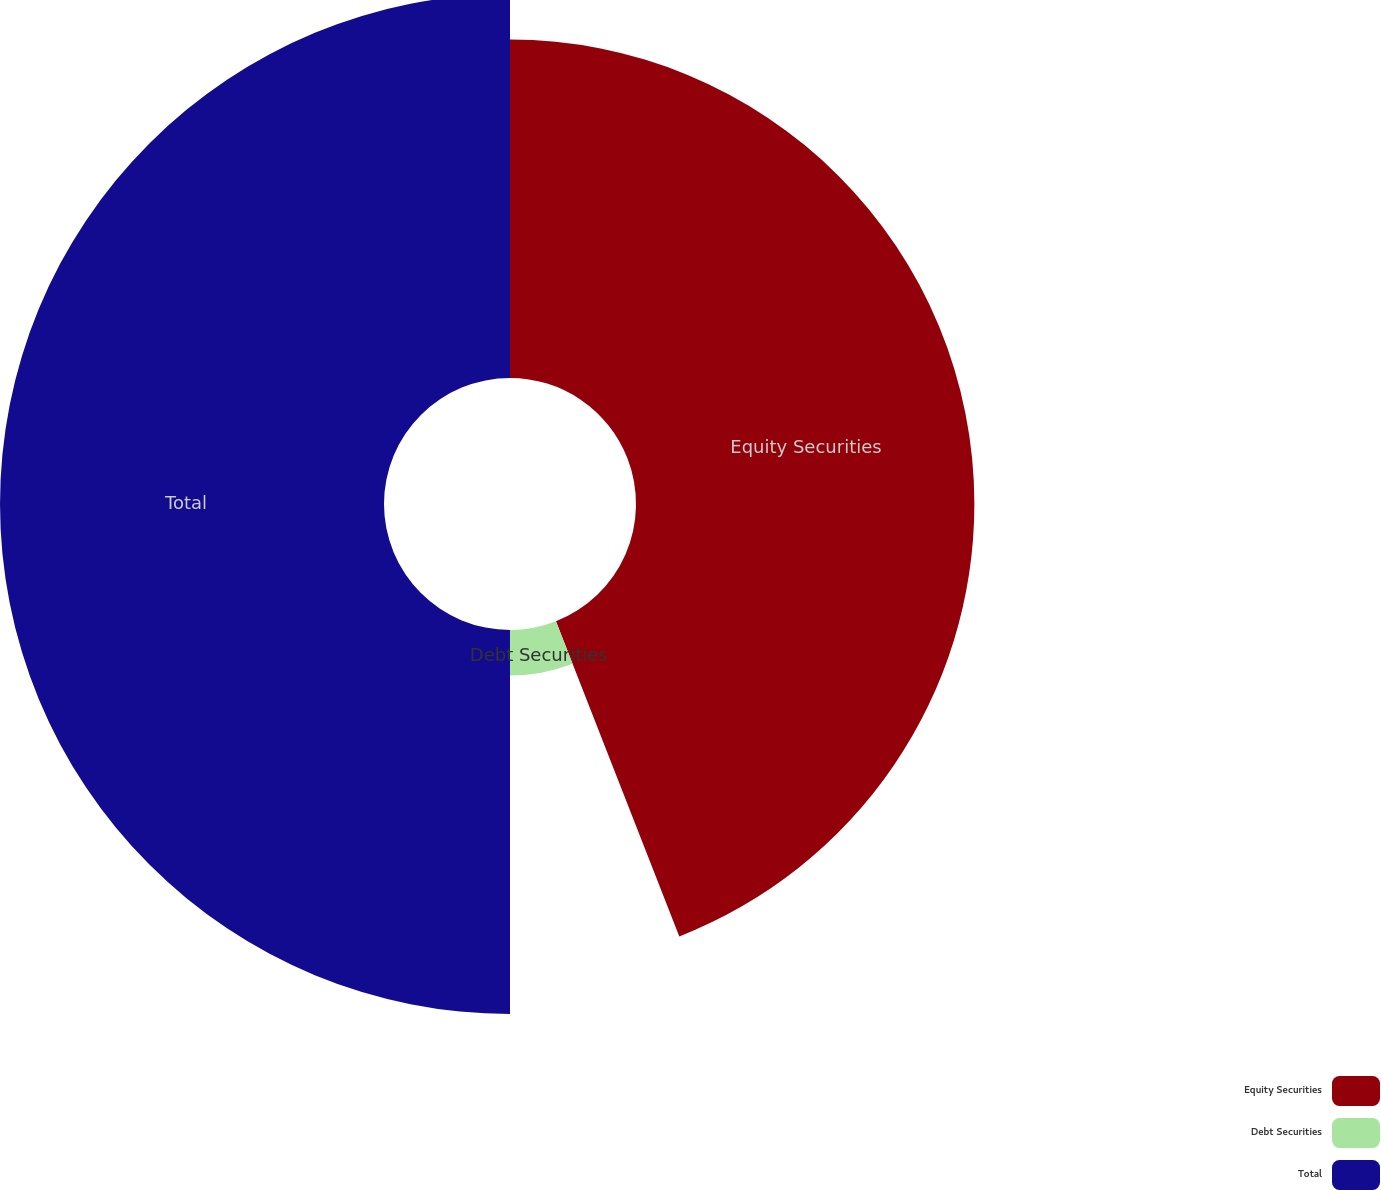Convert chart. <chart><loc_0><loc_0><loc_500><loc_500><pie_chart><fcel>Equity Securities<fcel>Debt Securities<fcel>Total<nl><fcel>44.06%<fcel>5.94%<fcel>50.0%<nl></chart> 